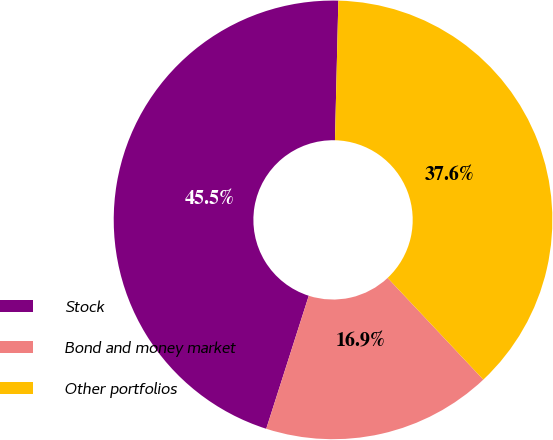Convert chart. <chart><loc_0><loc_0><loc_500><loc_500><pie_chart><fcel>Stock<fcel>Bond and money market<fcel>Other portfolios<nl><fcel>45.46%<fcel>16.94%<fcel>37.6%<nl></chart> 